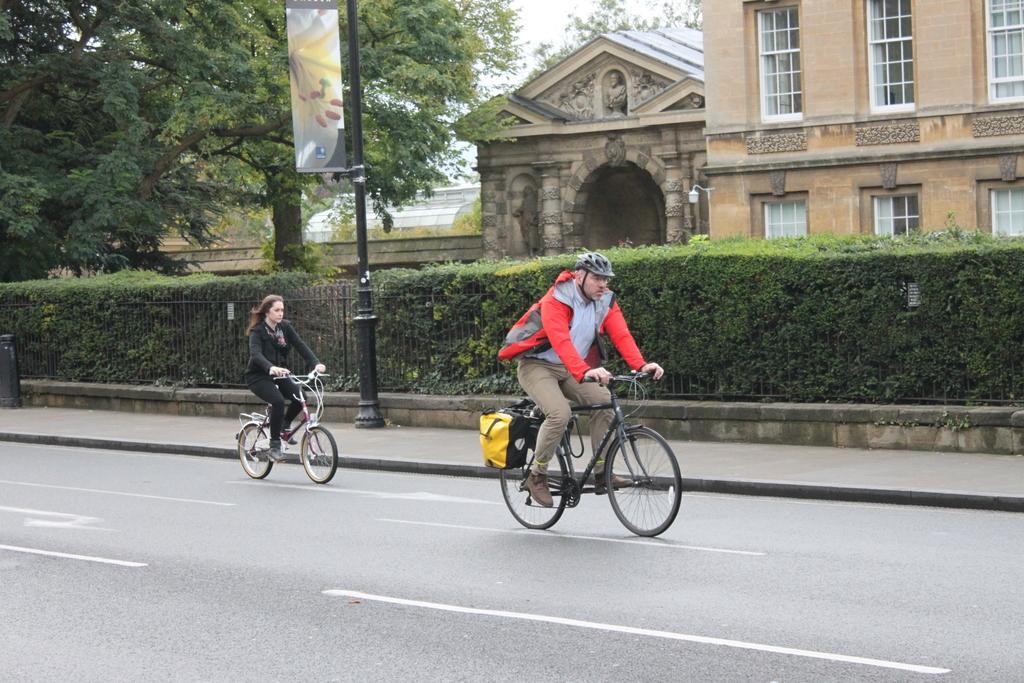Please provide a concise description of this image. In the image we can see a man and a woman wearing clothes and shoes. They are riding on the road with the help of bicycle, this is a road and white lines on the road. This is a helmet, pole, poster, trees, plant, fence, building and windows of the building, and the sky. 